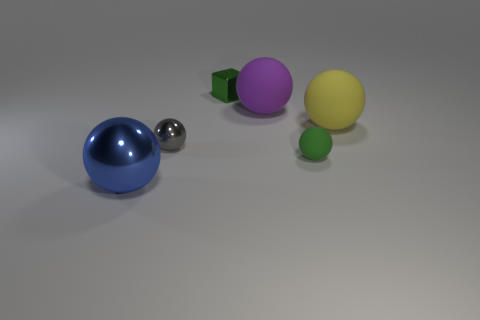What is the shape of the object that is left of the shiny ball that is behind the big blue object?
Offer a very short reply. Sphere. What is the size of the matte sphere that is behind the yellow rubber object?
Make the answer very short. Large. Is the material of the purple object the same as the big blue thing?
Provide a short and direct response. No. What is the shape of the blue object that is made of the same material as the gray sphere?
Your answer should be very brief. Sphere. Are there any other things of the same color as the small matte sphere?
Offer a very short reply. Yes. What is the color of the shiny ball right of the blue metallic sphere?
Provide a succinct answer. Gray. There is a small metallic object behind the yellow ball; is it the same color as the small rubber ball?
Your response must be concise. Yes. There is a large blue object that is the same shape as the small gray metallic object; what is its material?
Offer a terse response. Metal. What number of objects have the same size as the yellow sphere?
Your answer should be very brief. 2. The small gray object has what shape?
Provide a short and direct response. Sphere. 